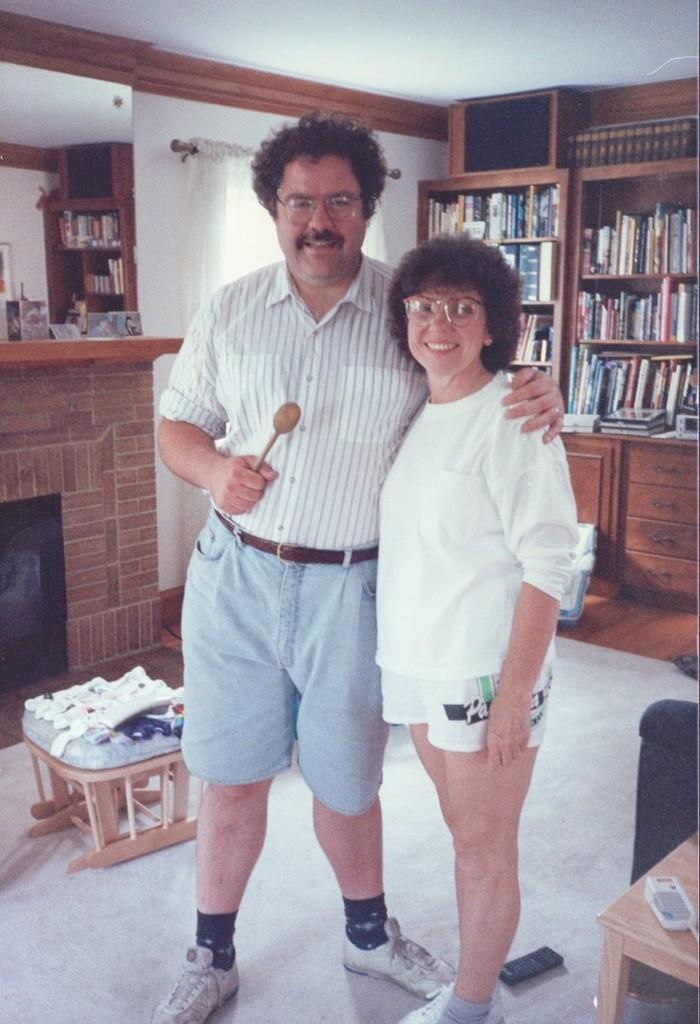How would you summarize this image in a sentence or two? In this Image I see a man and a woman who are standing and both of them are smiling. In the background I see the rack full of books, table and the wall. 